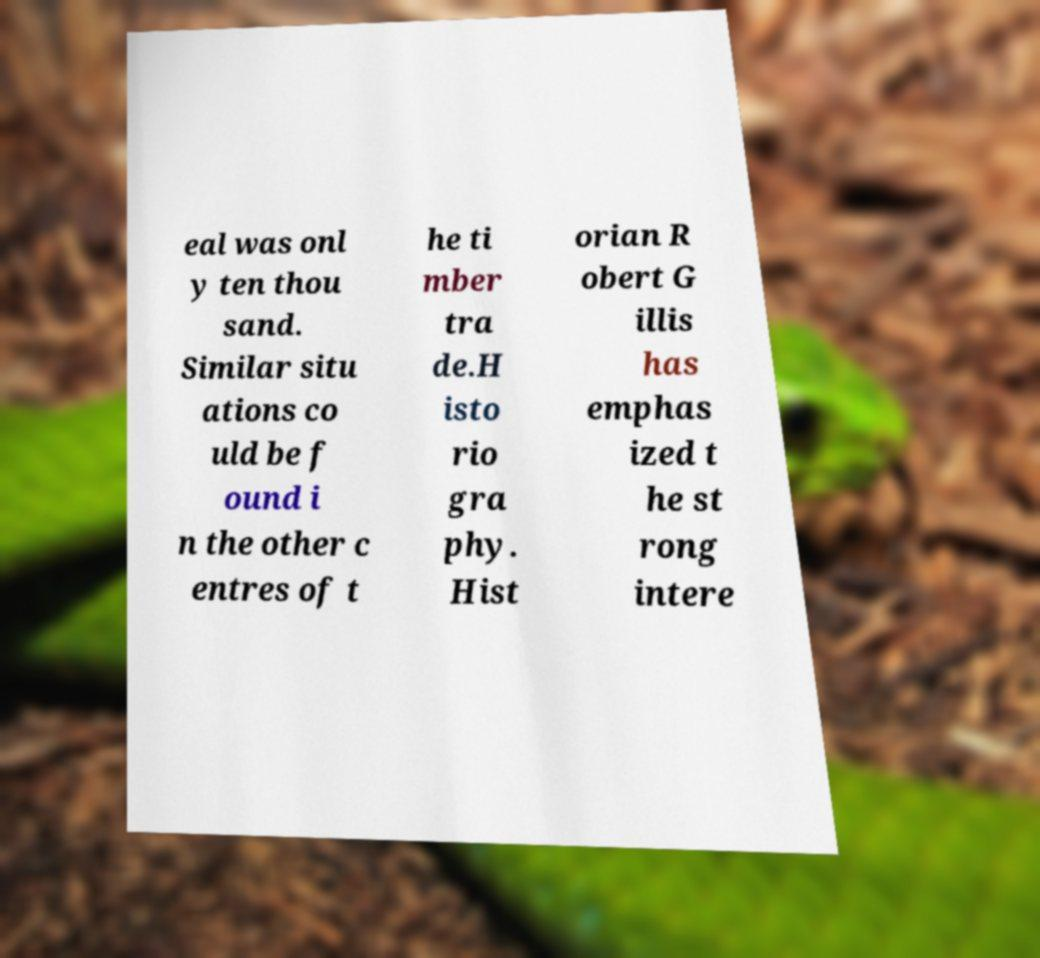Can you read and provide the text displayed in the image?This photo seems to have some interesting text. Can you extract and type it out for me? eal was onl y ten thou sand. Similar situ ations co uld be f ound i n the other c entres of t he ti mber tra de.H isto rio gra phy. Hist orian R obert G illis has emphas ized t he st rong intere 